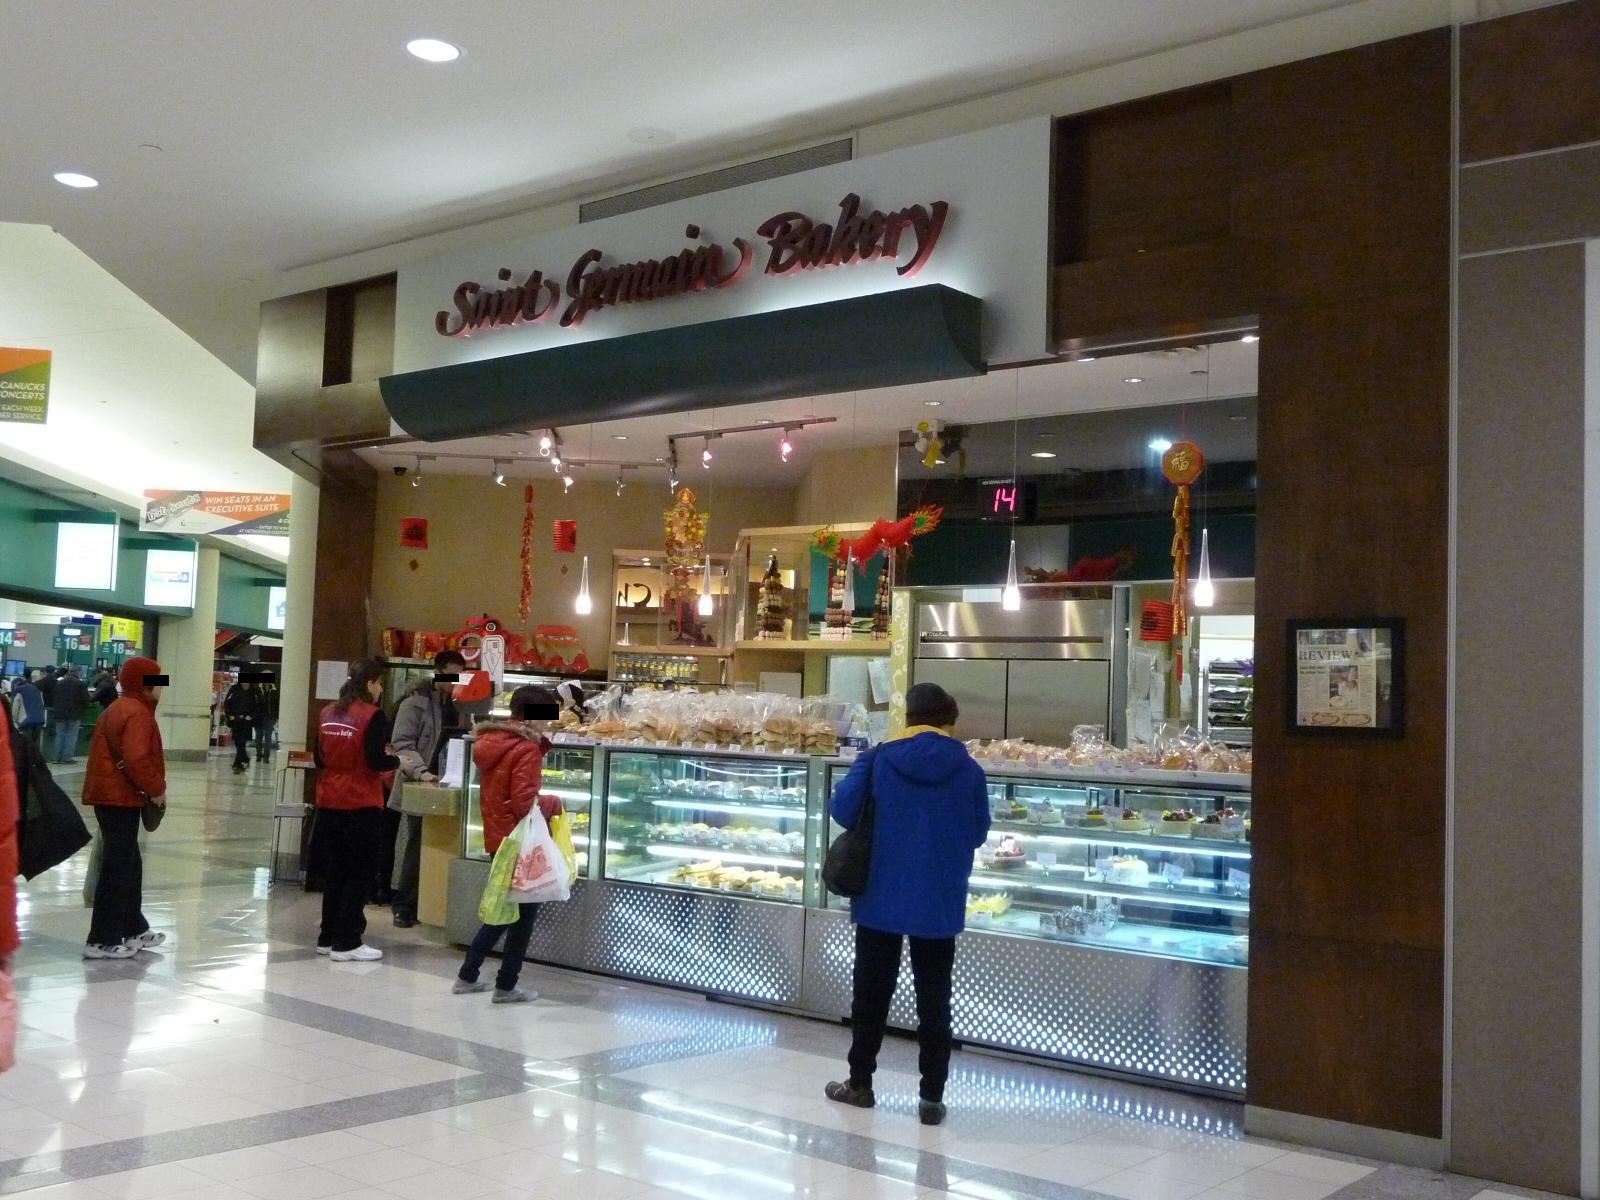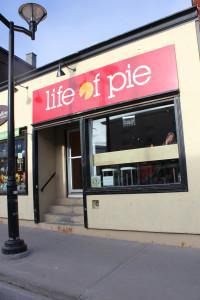The first image is the image on the left, the second image is the image on the right. For the images shown, is this caption "One of the store fronts has a brown awning." true? Answer yes or no. No. The first image is the image on the left, the second image is the image on the right. Assess this claim about the two images: "Front doors are visible in both images.". Correct or not? Answer yes or no. No. 